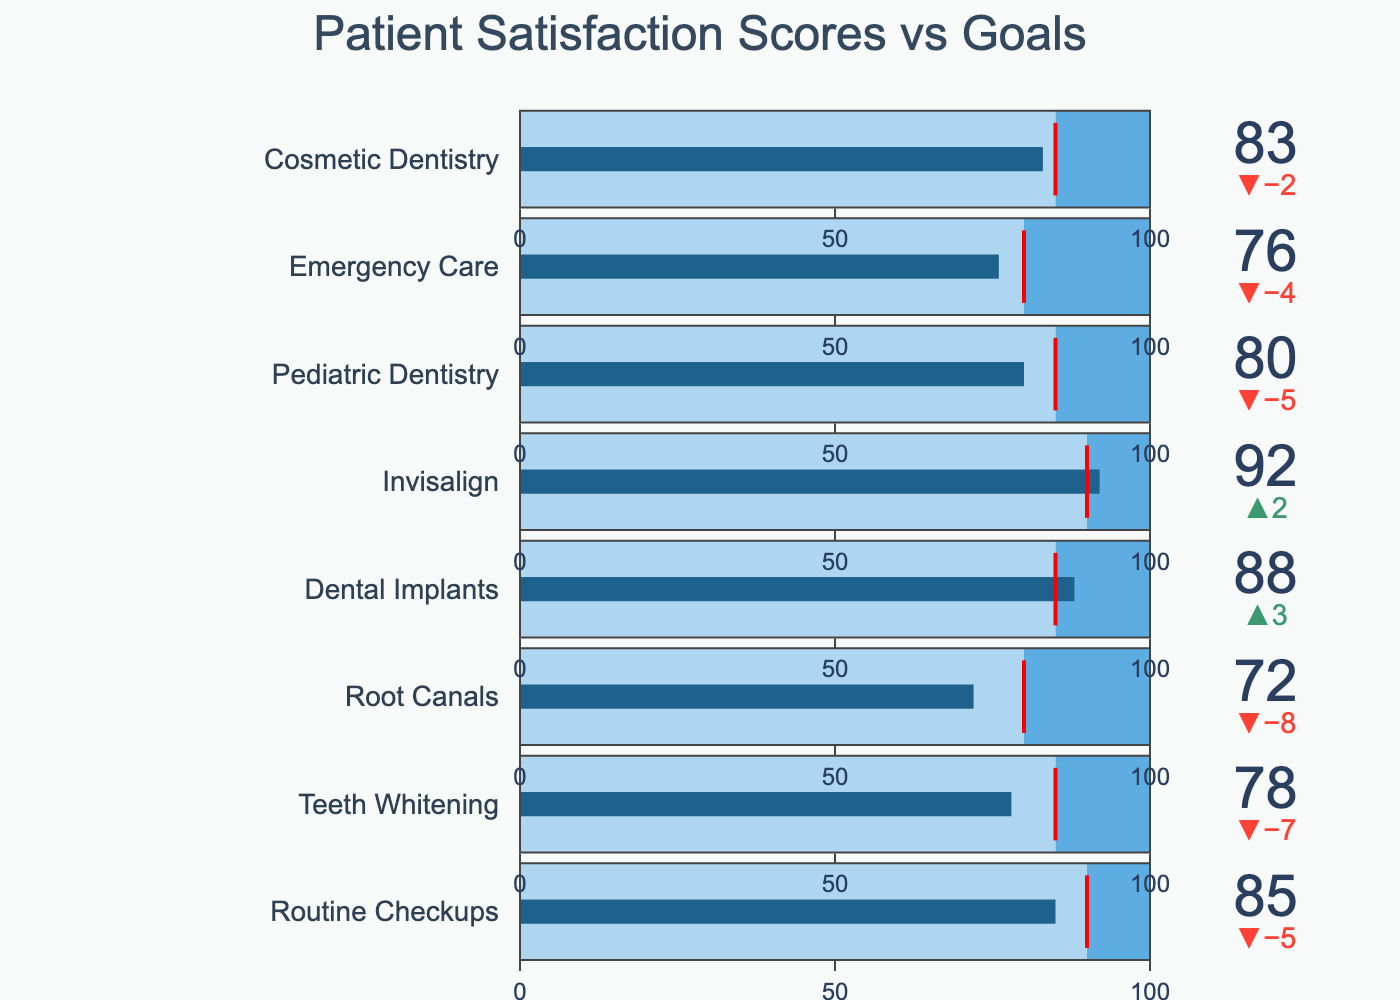What is the title of the figure? The title of the figure is prominently displayed at the top.
Answer: Patient Satisfaction Scores vs Goals What color represents the actual satisfaction scores on the bullet chart? The actual satisfaction scores are represented by a distinct bar color. The color of this bar is dark blue.
Answer: Dark blue Which service has the highest actual satisfaction score? By visually comparing the lengths of the dark blue bars in the bullet chart, we identify the service associated with the longest bar. Invisalign has the highest actual score.
Answer: Invisalign How many services did not meet their goal? Count the number of services where the dark blue bar (actual score) does not reach the red threshold line (goal). There are six services that did not meet their goals: Routine Checkups, Teeth Whitening, Root Canals, Pediatric Dentistry, Emergency Care, and Cosmetic Dentistry.
Answer: Six For the service 'Dental Implants', how does the actual score compare with the goal? Look at the placement of the dark blue bar relative to the red threshold line for 'Dental Implants'. The actual score exceeds the goal.
Answer: Exceeds How does Cosmetic Dentistry’s satisfaction score compare to its goal? Examine the dark blue bar (Cosmetic Dentistry’s satisfaction score) and see if it meets or exceeds the red threshold line (goal). The satisfaction score does not reach the goal.
Answer: Does not reach What’s the average goal for all services? Sum up all the goal values and divide by the number of services. (90 + 85 + 80 + 85 + 90 + 85 + 80 + 85) / 8 = 85
Answer: 85 Which service has the smallest gap between the actual score and the goal? Calculate the difference between the actual score and the goal for each service and find the service with the smallest difference. Dental Implants has the smallest gap (88 - 85 = 3).
Answer: Dental Implants If the full length of the bullet represents 100 points, what percentage of the maximum score does Pediatric Dentistry achieve? Divide Pediatric Dentistry's actual score by the maximum and multiply by 100 to get the percentage. (80/100) * 100 = 80%
Answer: 80% Which service has a higher satisfaction score, Routine Checkups or Teeth Whitening? Compare the dark blue bars for Routine Checkups and Teeth Whitening. The actual score for Routine Checkups (85) is higher than that for Teeth Whitening (78).
Answer: Routine Checkups 